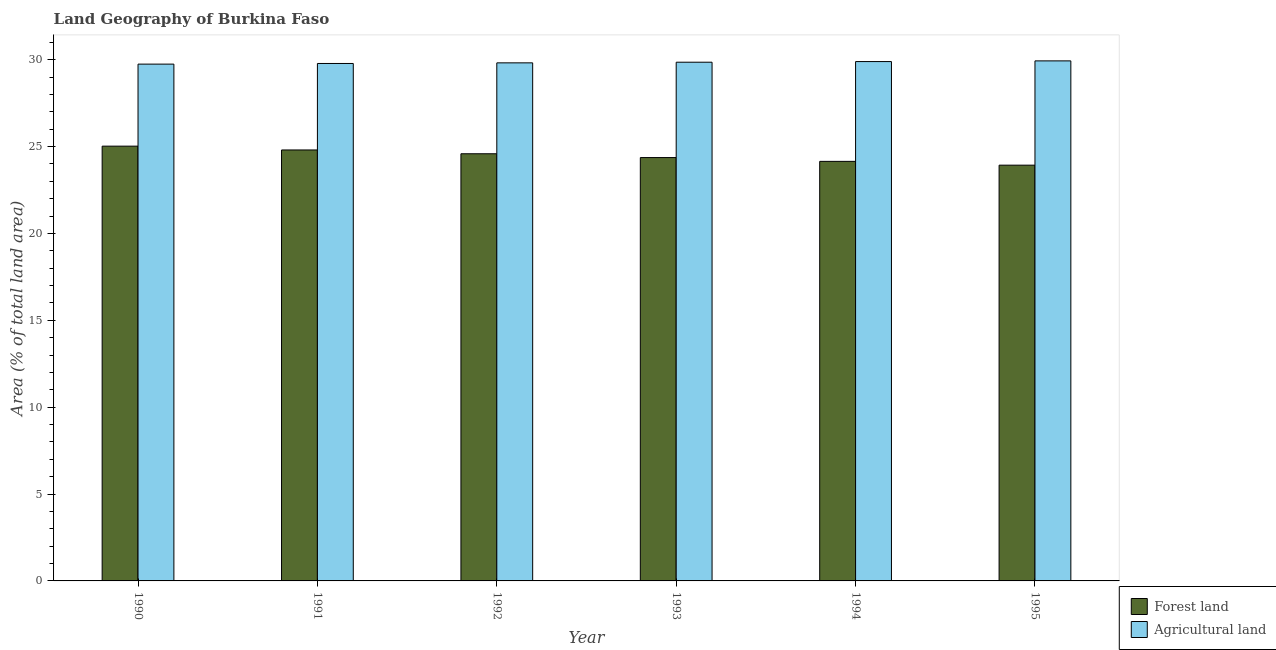Are the number of bars per tick equal to the number of legend labels?
Offer a terse response. Yes. How many bars are there on the 3rd tick from the left?
Offer a terse response. 2. What is the label of the 3rd group of bars from the left?
Provide a short and direct response. 1992. What is the percentage of land area under agriculture in 1990?
Keep it short and to the point. 29.75. Across all years, what is the maximum percentage of land area under forests?
Your answer should be very brief. 25.03. Across all years, what is the minimum percentage of land area under agriculture?
Your response must be concise. 29.75. In which year was the percentage of land area under forests maximum?
Give a very brief answer. 1990. What is the total percentage of land area under forests in the graph?
Offer a terse response. 146.87. What is the difference between the percentage of land area under forests in 1991 and that in 1992?
Ensure brevity in your answer.  0.22. What is the difference between the percentage of land area under agriculture in 1991 and the percentage of land area under forests in 1992?
Offer a terse response. -0.04. What is the average percentage of land area under agriculture per year?
Offer a very short reply. 29.84. What is the ratio of the percentage of land area under forests in 1994 to that in 1995?
Offer a terse response. 1.01. Is the difference between the percentage of land area under forests in 1990 and 1992 greater than the difference between the percentage of land area under agriculture in 1990 and 1992?
Offer a terse response. No. What is the difference between the highest and the second highest percentage of land area under forests?
Give a very brief answer. 0.22. What is the difference between the highest and the lowest percentage of land area under agriculture?
Keep it short and to the point. 0.19. What does the 2nd bar from the left in 1993 represents?
Offer a terse response. Agricultural land. What does the 1st bar from the right in 1993 represents?
Provide a short and direct response. Agricultural land. Are all the bars in the graph horizontal?
Make the answer very short. No. Are the values on the major ticks of Y-axis written in scientific E-notation?
Your answer should be compact. No. Does the graph contain any zero values?
Offer a very short reply. No. How many legend labels are there?
Provide a succinct answer. 2. What is the title of the graph?
Offer a very short reply. Land Geography of Burkina Faso. What is the label or title of the X-axis?
Your response must be concise. Year. What is the label or title of the Y-axis?
Provide a short and direct response. Area (% of total land area). What is the Area (% of total land area) of Forest land in 1990?
Make the answer very short. 25.03. What is the Area (% of total land area) in Agricultural land in 1990?
Ensure brevity in your answer.  29.75. What is the Area (% of total land area) in Forest land in 1991?
Give a very brief answer. 24.81. What is the Area (% of total land area) of Agricultural land in 1991?
Give a very brief answer. 29.78. What is the Area (% of total land area) of Forest land in 1992?
Your answer should be very brief. 24.59. What is the Area (% of total land area) of Agricultural land in 1992?
Provide a succinct answer. 29.82. What is the Area (% of total land area) of Forest land in 1993?
Keep it short and to the point. 24.37. What is the Area (% of total land area) of Agricultural land in 1993?
Offer a terse response. 29.86. What is the Area (% of total land area) of Forest land in 1994?
Keep it short and to the point. 24.15. What is the Area (% of total land area) in Agricultural land in 1994?
Provide a short and direct response. 29.89. What is the Area (% of total land area) in Forest land in 1995?
Provide a short and direct response. 23.93. What is the Area (% of total land area) in Agricultural land in 1995?
Your response must be concise. 29.93. Across all years, what is the maximum Area (% of total land area) in Forest land?
Provide a short and direct response. 25.03. Across all years, what is the maximum Area (% of total land area) of Agricultural land?
Your answer should be very brief. 29.93. Across all years, what is the minimum Area (% of total land area) in Forest land?
Your answer should be compact. 23.93. Across all years, what is the minimum Area (% of total land area) in Agricultural land?
Offer a very short reply. 29.75. What is the total Area (% of total land area) in Forest land in the graph?
Your answer should be very brief. 146.87. What is the total Area (% of total land area) in Agricultural land in the graph?
Your response must be concise. 179.04. What is the difference between the Area (% of total land area) in Forest land in 1990 and that in 1991?
Ensure brevity in your answer.  0.22. What is the difference between the Area (% of total land area) of Agricultural land in 1990 and that in 1991?
Ensure brevity in your answer.  -0.04. What is the difference between the Area (% of total land area) of Forest land in 1990 and that in 1992?
Ensure brevity in your answer.  0.44. What is the difference between the Area (% of total land area) of Agricultural land in 1990 and that in 1992?
Keep it short and to the point. -0.07. What is the difference between the Area (% of total land area) in Forest land in 1990 and that in 1993?
Your response must be concise. 0.66. What is the difference between the Area (% of total land area) in Agricultural land in 1990 and that in 1993?
Offer a very short reply. -0.11. What is the difference between the Area (% of total land area) of Forest land in 1990 and that in 1994?
Offer a very short reply. 0.88. What is the difference between the Area (% of total land area) in Agricultural land in 1990 and that in 1994?
Your answer should be very brief. -0.15. What is the difference between the Area (% of total land area) of Forest land in 1990 and that in 1995?
Offer a very short reply. 1.09. What is the difference between the Area (% of total land area) of Agricultural land in 1990 and that in 1995?
Keep it short and to the point. -0.19. What is the difference between the Area (% of total land area) in Forest land in 1991 and that in 1992?
Your answer should be very brief. 0.22. What is the difference between the Area (% of total land area) in Agricultural land in 1991 and that in 1992?
Give a very brief answer. -0.04. What is the difference between the Area (% of total land area) of Forest land in 1991 and that in 1993?
Give a very brief answer. 0.44. What is the difference between the Area (% of total land area) in Agricultural land in 1991 and that in 1993?
Offer a terse response. -0.07. What is the difference between the Area (% of total land area) in Forest land in 1991 and that in 1994?
Make the answer very short. 0.66. What is the difference between the Area (% of total land area) of Agricultural land in 1991 and that in 1994?
Give a very brief answer. -0.11. What is the difference between the Area (% of total land area) of Forest land in 1991 and that in 1995?
Ensure brevity in your answer.  0.88. What is the difference between the Area (% of total land area) of Agricultural land in 1991 and that in 1995?
Offer a very short reply. -0.15. What is the difference between the Area (% of total land area) in Forest land in 1992 and that in 1993?
Give a very brief answer. 0.22. What is the difference between the Area (% of total land area) in Agricultural land in 1992 and that in 1993?
Offer a terse response. -0.04. What is the difference between the Area (% of total land area) in Forest land in 1992 and that in 1994?
Ensure brevity in your answer.  0.44. What is the difference between the Area (% of total land area) of Agricultural land in 1992 and that in 1994?
Your answer should be compact. -0.07. What is the difference between the Area (% of total land area) in Forest land in 1992 and that in 1995?
Your answer should be very brief. 0.66. What is the difference between the Area (% of total land area) in Agricultural land in 1992 and that in 1995?
Offer a very short reply. -0.11. What is the difference between the Area (% of total land area) of Forest land in 1993 and that in 1994?
Make the answer very short. 0.22. What is the difference between the Area (% of total land area) of Agricultural land in 1993 and that in 1994?
Give a very brief answer. -0.04. What is the difference between the Area (% of total land area) of Forest land in 1993 and that in 1995?
Keep it short and to the point. 0.44. What is the difference between the Area (% of total land area) of Agricultural land in 1993 and that in 1995?
Ensure brevity in your answer.  -0.08. What is the difference between the Area (% of total land area) of Forest land in 1994 and that in 1995?
Ensure brevity in your answer.  0.22. What is the difference between the Area (% of total land area) of Agricultural land in 1994 and that in 1995?
Ensure brevity in your answer.  -0.04. What is the difference between the Area (% of total land area) in Forest land in 1990 and the Area (% of total land area) in Agricultural land in 1991?
Offer a very short reply. -4.76. What is the difference between the Area (% of total land area) in Forest land in 1990 and the Area (% of total land area) in Agricultural land in 1992?
Keep it short and to the point. -4.8. What is the difference between the Area (% of total land area) of Forest land in 1990 and the Area (% of total land area) of Agricultural land in 1993?
Your answer should be very brief. -4.83. What is the difference between the Area (% of total land area) of Forest land in 1990 and the Area (% of total land area) of Agricultural land in 1994?
Offer a very short reply. -4.87. What is the difference between the Area (% of total land area) in Forest land in 1990 and the Area (% of total land area) in Agricultural land in 1995?
Your response must be concise. -4.91. What is the difference between the Area (% of total land area) of Forest land in 1991 and the Area (% of total land area) of Agricultural land in 1992?
Give a very brief answer. -5.01. What is the difference between the Area (% of total land area) of Forest land in 1991 and the Area (% of total land area) of Agricultural land in 1993?
Your response must be concise. -5.05. What is the difference between the Area (% of total land area) of Forest land in 1991 and the Area (% of total land area) of Agricultural land in 1994?
Your answer should be compact. -5.09. What is the difference between the Area (% of total land area) in Forest land in 1991 and the Area (% of total land area) in Agricultural land in 1995?
Make the answer very short. -5.13. What is the difference between the Area (% of total land area) in Forest land in 1992 and the Area (% of total land area) in Agricultural land in 1993?
Ensure brevity in your answer.  -5.27. What is the difference between the Area (% of total land area) of Forest land in 1992 and the Area (% of total land area) of Agricultural land in 1994?
Keep it short and to the point. -5.31. What is the difference between the Area (% of total land area) of Forest land in 1992 and the Area (% of total land area) of Agricultural land in 1995?
Your answer should be very brief. -5.35. What is the difference between the Area (% of total land area) of Forest land in 1993 and the Area (% of total land area) of Agricultural land in 1994?
Your response must be concise. -5.53. What is the difference between the Area (% of total land area) of Forest land in 1993 and the Area (% of total land area) of Agricultural land in 1995?
Your response must be concise. -5.57. What is the difference between the Area (% of total land area) in Forest land in 1994 and the Area (% of total land area) in Agricultural land in 1995?
Provide a succinct answer. -5.78. What is the average Area (% of total land area) in Forest land per year?
Give a very brief answer. 24.48. What is the average Area (% of total land area) in Agricultural land per year?
Offer a terse response. 29.84. In the year 1990, what is the difference between the Area (% of total land area) in Forest land and Area (% of total land area) in Agricultural land?
Give a very brief answer. -4.72. In the year 1991, what is the difference between the Area (% of total land area) of Forest land and Area (% of total land area) of Agricultural land?
Your answer should be compact. -4.98. In the year 1992, what is the difference between the Area (% of total land area) in Forest land and Area (% of total land area) in Agricultural land?
Ensure brevity in your answer.  -5.23. In the year 1993, what is the difference between the Area (% of total land area) in Forest land and Area (% of total land area) in Agricultural land?
Offer a terse response. -5.49. In the year 1994, what is the difference between the Area (% of total land area) of Forest land and Area (% of total land area) of Agricultural land?
Offer a terse response. -5.74. In the year 1995, what is the difference between the Area (% of total land area) in Forest land and Area (% of total land area) in Agricultural land?
Provide a succinct answer. -6. What is the ratio of the Area (% of total land area) in Forest land in 1990 to that in 1991?
Give a very brief answer. 1.01. What is the ratio of the Area (% of total land area) in Forest land in 1990 to that in 1992?
Your answer should be very brief. 1.02. What is the ratio of the Area (% of total land area) of Agricultural land in 1990 to that in 1992?
Your answer should be compact. 1. What is the ratio of the Area (% of total land area) in Forest land in 1990 to that in 1993?
Provide a short and direct response. 1.03. What is the ratio of the Area (% of total land area) in Forest land in 1990 to that in 1994?
Your answer should be very brief. 1.04. What is the ratio of the Area (% of total land area) of Agricultural land in 1990 to that in 1994?
Your answer should be compact. 1. What is the ratio of the Area (% of total land area) in Forest land in 1990 to that in 1995?
Offer a very short reply. 1.05. What is the ratio of the Area (% of total land area) of Forest land in 1991 to that in 1992?
Make the answer very short. 1.01. What is the ratio of the Area (% of total land area) of Forest land in 1991 to that in 1994?
Provide a short and direct response. 1.03. What is the ratio of the Area (% of total land area) of Agricultural land in 1991 to that in 1994?
Your answer should be compact. 1. What is the ratio of the Area (% of total land area) in Forest land in 1991 to that in 1995?
Offer a terse response. 1.04. What is the ratio of the Area (% of total land area) of Agricultural land in 1991 to that in 1995?
Give a very brief answer. 0.99. What is the ratio of the Area (% of total land area) of Agricultural land in 1992 to that in 1993?
Your answer should be compact. 1. What is the ratio of the Area (% of total land area) in Forest land in 1992 to that in 1994?
Give a very brief answer. 1.02. What is the ratio of the Area (% of total land area) in Agricultural land in 1992 to that in 1994?
Ensure brevity in your answer.  1. What is the ratio of the Area (% of total land area) in Forest land in 1992 to that in 1995?
Your answer should be very brief. 1.03. What is the ratio of the Area (% of total land area) in Forest land in 1993 to that in 1994?
Your answer should be very brief. 1.01. What is the ratio of the Area (% of total land area) in Forest land in 1993 to that in 1995?
Offer a terse response. 1.02. What is the ratio of the Area (% of total land area) in Agricultural land in 1993 to that in 1995?
Offer a very short reply. 1. What is the ratio of the Area (% of total land area) in Forest land in 1994 to that in 1995?
Offer a very short reply. 1.01. What is the difference between the highest and the second highest Area (% of total land area) in Forest land?
Your answer should be compact. 0.22. What is the difference between the highest and the second highest Area (% of total land area) of Agricultural land?
Ensure brevity in your answer.  0.04. What is the difference between the highest and the lowest Area (% of total land area) in Forest land?
Ensure brevity in your answer.  1.09. What is the difference between the highest and the lowest Area (% of total land area) of Agricultural land?
Ensure brevity in your answer.  0.19. 